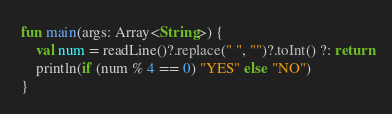Convert code to text. <code><loc_0><loc_0><loc_500><loc_500><_Kotlin_>fun main(args: Array<String>) {
    val num = readLine()?.replace(" ", "")?.toInt() ?: return
    println(if (num % 4 == 0) "YES" else "NO")
}</code> 